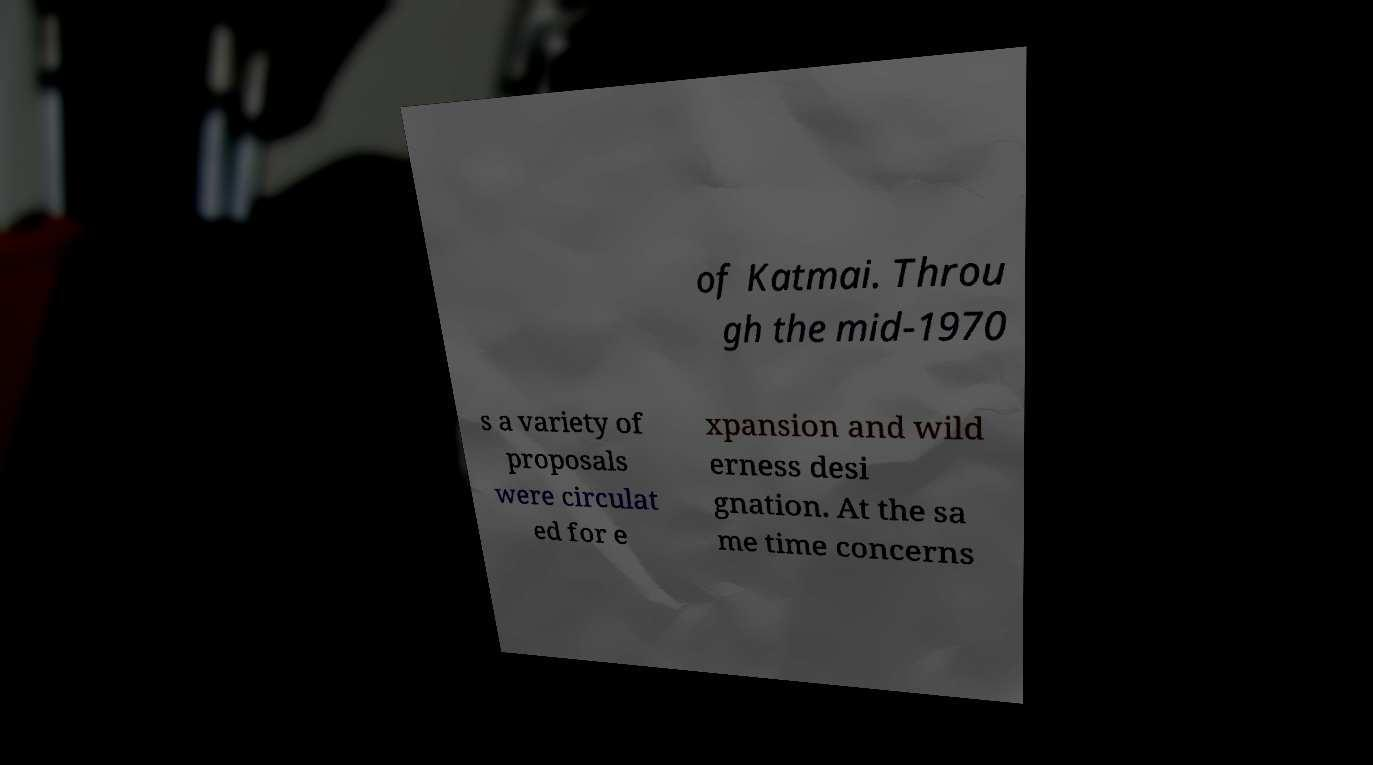Can you read and provide the text displayed in the image?This photo seems to have some interesting text. Can you extract and type it out for me? of Katmai. Throu gh the mid-1970 s a variety of proposals were circulat ed for e xpansion and wild erness desi gnation. At the sa me time concerns 